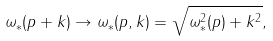<formula> <loc_0><loc_0><loc_500><loc_500>\omega _ { \ast } ( p + k ) \rightarrow \omega _ { \ast } ( p , k ) = \sqrt { \omega _ { \ast } ^ { 2 } ( p ) + k ^ { 2 } } ,</formula> 